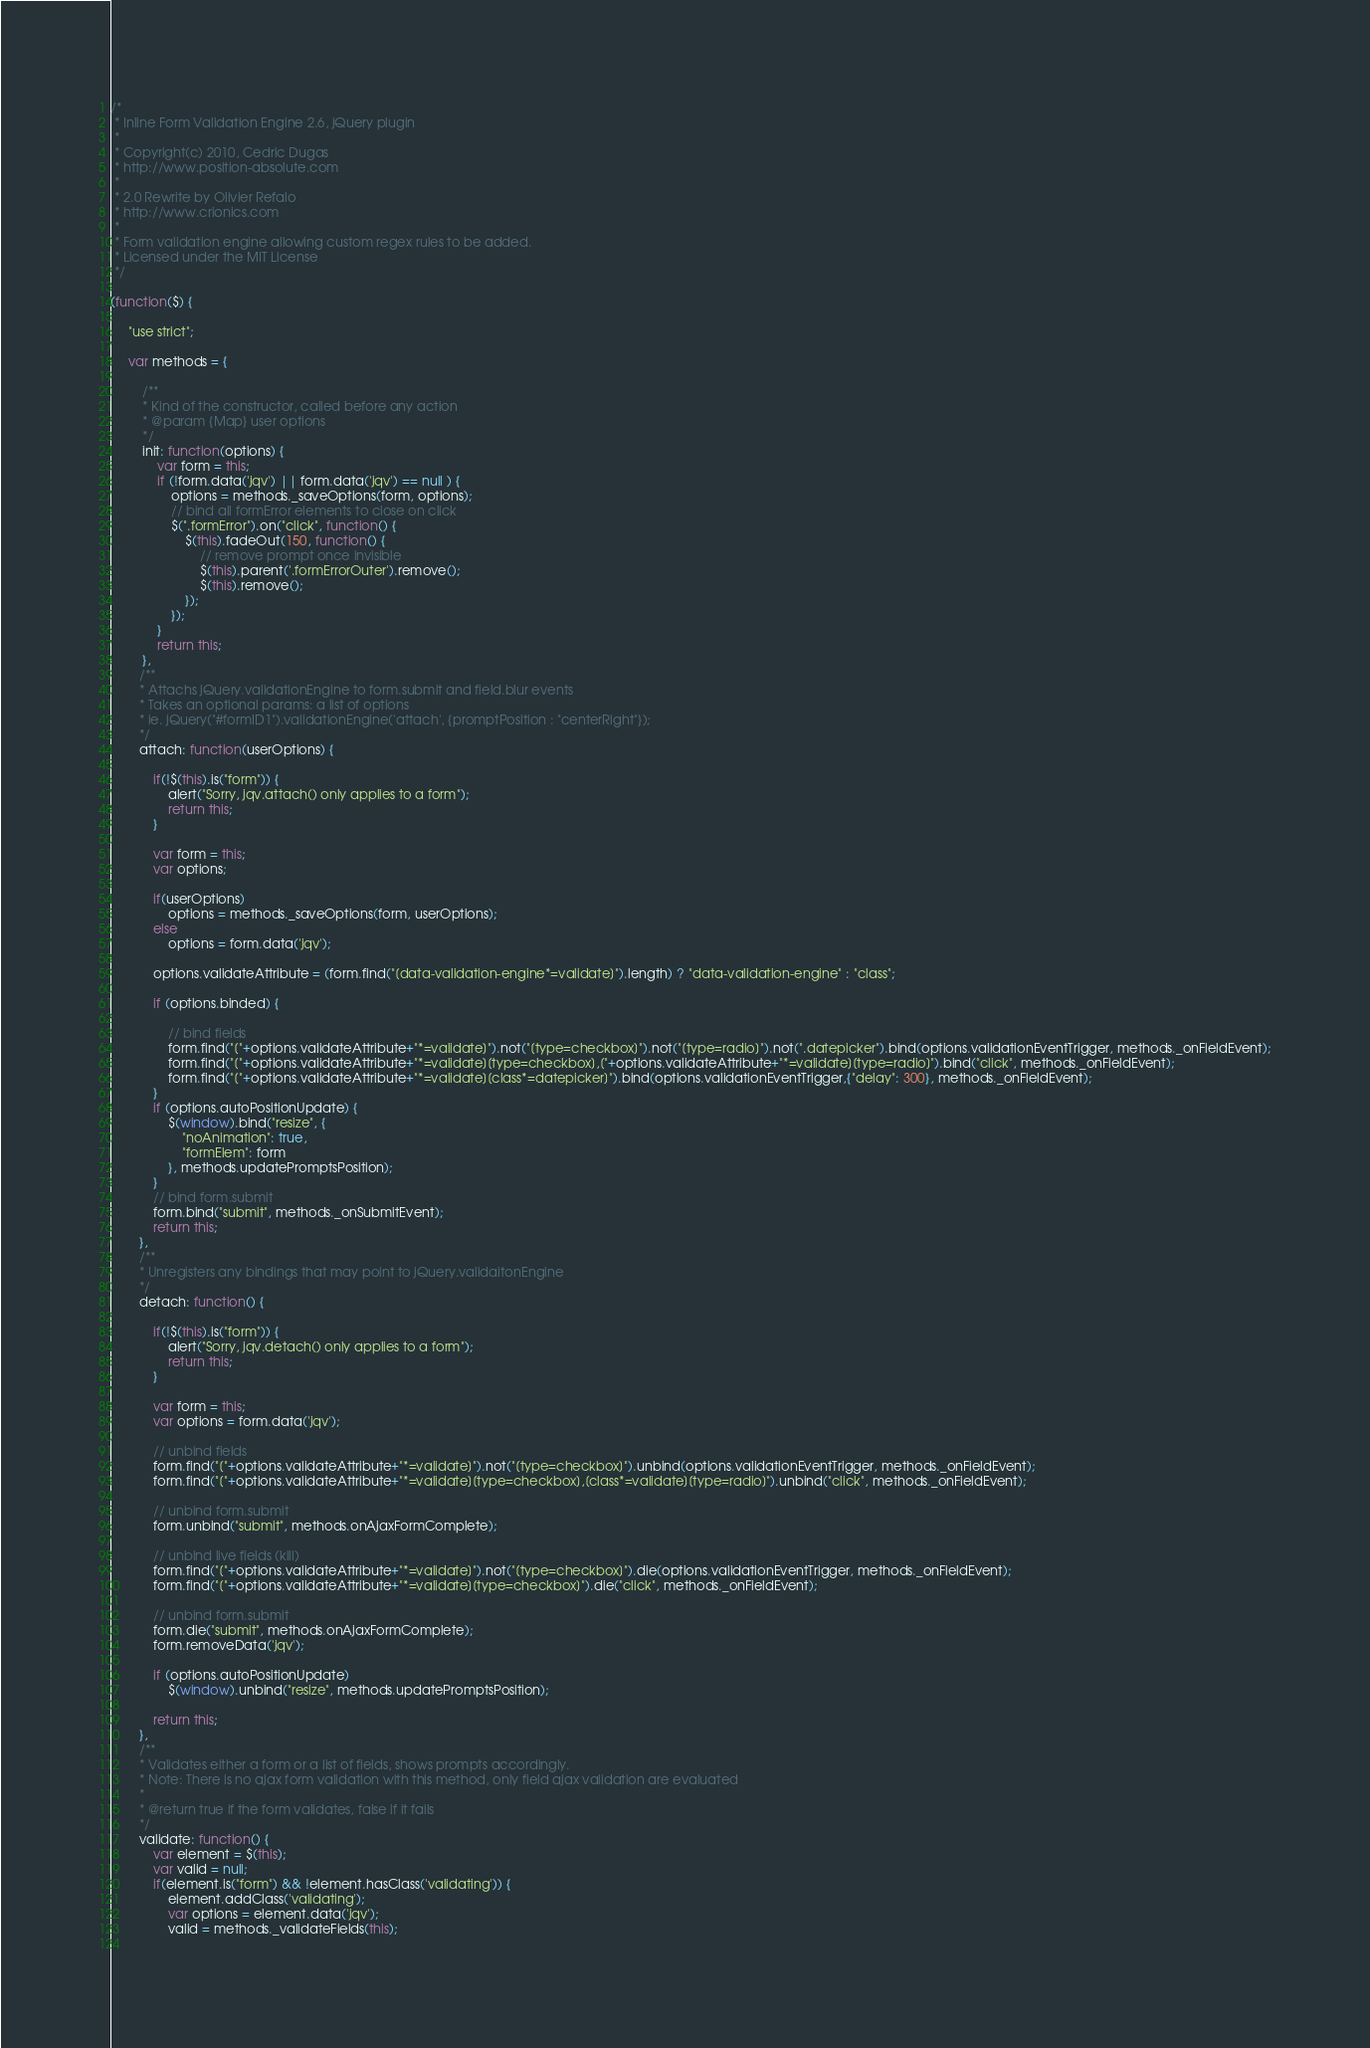<code> <loc_0><loc_0><loc_500><loc_500><_JavaScript_>/*
 * Inline Form Validation Engine 2.6, jQuery plugin
 *
 * Copyright(c) 2010, Cedric Dugas
 * http://www.position-absolute.com
 *
 * 2.0 Rewrite by Olivier Refalo
 * http://www.crionics.com
 *
 * Form validation engine allowing custom regex rules to be added.
 * Licensed under the MIT License
 */

(function($) {

	 "use strict";

	 var methods = {

		 /**
		 * Kind of the constructor, called before any action
		 * @param {Map} user options
		 */
		 init: function(options) {
			 var form = this;
			 if (!form.data('jqv') || form.data('jqv') == null ) {
				 options = methods._saveOptions(form, options);
				 // bind all formError elements to close on click
				 $(".formError").on("click", function() {
					 $(this).fadeOut(150, function() {
						 // remove prompt once invisible
						 $(this).parent('.formErrorOuter').remove();
						 $(this).remove();
					 });
				 });
			 }
			 return this;
		 },
		/**
		* Attachs jQuery.validationEngine to form.submit and field.blur events
		* Takes an optional params: a list of options
		* ie. jQuery("#formID1").validationEngine('attach', {promptPosition : "centerRight"});
		*/
		attach: function(userOptions) {

			if(!$(this).is("form")) {
				alert("Sorry, jqv.attach() only applies to a form");
				return this;
			}
			
			var form = this;
			var options;

			if(userOptions)
				options = methods._saveOptions(form, userOptions);
			else
				options = form.data('jqv');

			options.validateAttribute = (form.find("[data-validation-engine*=validate]").length) ? "data-validation-engine" : "class";

			if (options.binded) {

				// bind fields
				form.find("["+options.validateAttribute+"*=validate]").not("[type=checkbox]").not("[type=radio]").not(".datepicker").bind(options.validationEventTrigger, methods._onFieldEvent);
				form.find("["+options.validateAttribute+"*=validate][type=checkbox],["+options.validateAttribute+"*=validate][type=radio]").bind("click", methods._onFieldEvent);
				form.find("["+options.validateAttribute+"*=validate][class*=datepicker]").bind(options.validationEventTrigger,{"delay": 300}, methods._onFieldEvent);
			}
			if (options.autoPositionUpdate) {
				$(window).bind("resize", {
					"noAnimation": true,
					"formElem": form
				}, methods.updatePromptsPosition);
			}
			// bind form.submit
			form.bind("submit", methods._onSubmitEvent);
			return this;
		},
		/**
		* Unregisters any bindings that may point to jQuery.validaitonEngine
		*/
		detach: function() {
			
			if(!$(this).is("form")) {
				alert("Sorry, jqv.detach() only applies to a form");
				return this;
			}

			var form = this;
			var options = form.data('jqv');

			// unbind fields
			form.find("["+options.validateAttribute+"*=validate]").not("[type=checkbox]").unbind(options.validationEventTrigger, methods._onFieldEvent);
			form.find("["+options.validateAttribute+"*=validate][type=checkbox],[class*=validate][type=radio]").unbind("click", methods._onFieldEvent);

			// unbind form.submit
			form.unbind("submit", methods.onAjaxFormComplete);

			// unbind live fields (kill)
			form.find("["+options.validateAttribute+"*=validate]").not("[type=checkbox]").die(options.validationEventTrigger, methods._onFieldEvent);
			form.find("["+options.validateAttribute+"*=validate][type=checkbox]").die("click", methods._onFieldEvent);

			// unbind form.submit
			form.die("submit", methods.onAjaxFormComplete);
			form.removeData('jqv');

			if (options.autoPositionUpdate)
				$(window).unbind("resize", methods.updatePromptsPosition);

			return this;
		},
		/**
		* Validates either a form or a list of fields, shows prompts accordingly.
		* Note: There is no ajax form validation with this method, only field ajax validation are evaluated
		*
		* @return true if the form validates, false if it fails
		*/
		validate: function() {
			var element = $(this);
			var valid = null;
			if(element.is("form") && !element.hasClass('validating')) {
				element.addClass('validating');
				var options = element.data('jqv');
				valid = methods._validateFields(this);
				</code> 